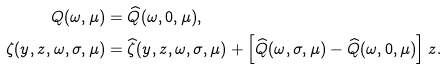<formula> <loc_0><loc_0><loc_500><loc_500>Q ( \omega , \mu ) & = \widehat { Q } ( \omega , 0 , \mu ) , \\ \zeta ( y , z , \omega , \sigma , \mu ) & = \widehat { \zeta } ( y , z , \omega , \sigma , \mu ) + \left [ \widehat { Q } ( \omega , \sigma , \mu ) - \widehat { Q } ( \omega , 0 , \mu ) \right ] z .</formula> 